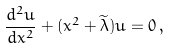<formula> <loc_0><loc_0><loc_500><loc_500>\frac { d ^ { 2 } u } { d x ^ { 2 } } + ( x ^ { 2 } + \widetilde { \lambda } ) u = 0 \, ,</formula> 